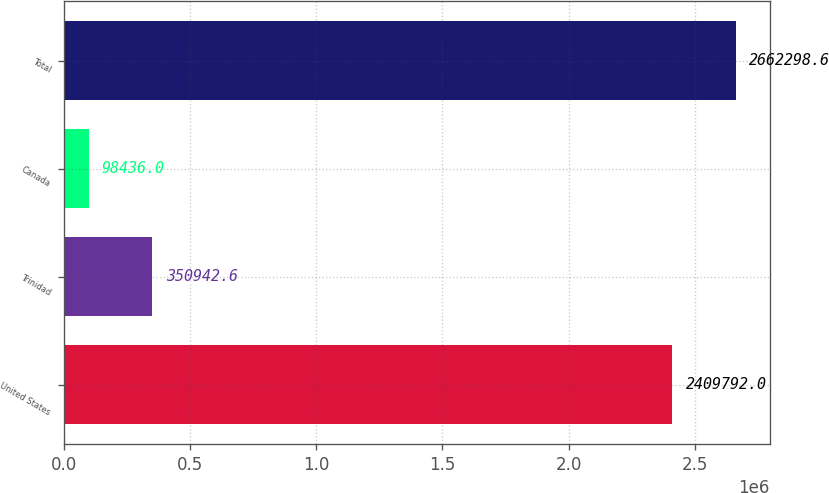<chart> <loc_0><loc_0><loc_500><loc_500><bar_chart><fcel>United States<fcel>Trinidad<fcel>Canada<fcel>Total<nl><fcel>2.40979e+06<fcel>350943<fcel>98436<fcel>2.6623e+06<nl></chart> 